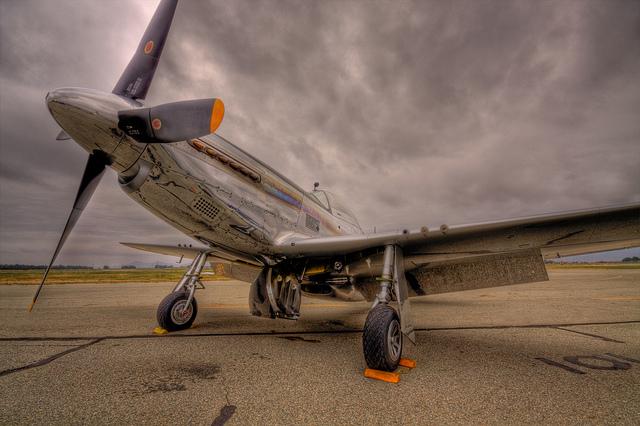What type of plane is this?
Concise answer only. Propeller. Is it cloudy?
Give a very brief answer. Yes. What is being used to prevent the wheels of the plane from rolling?
Concise answer only. Chocks. 